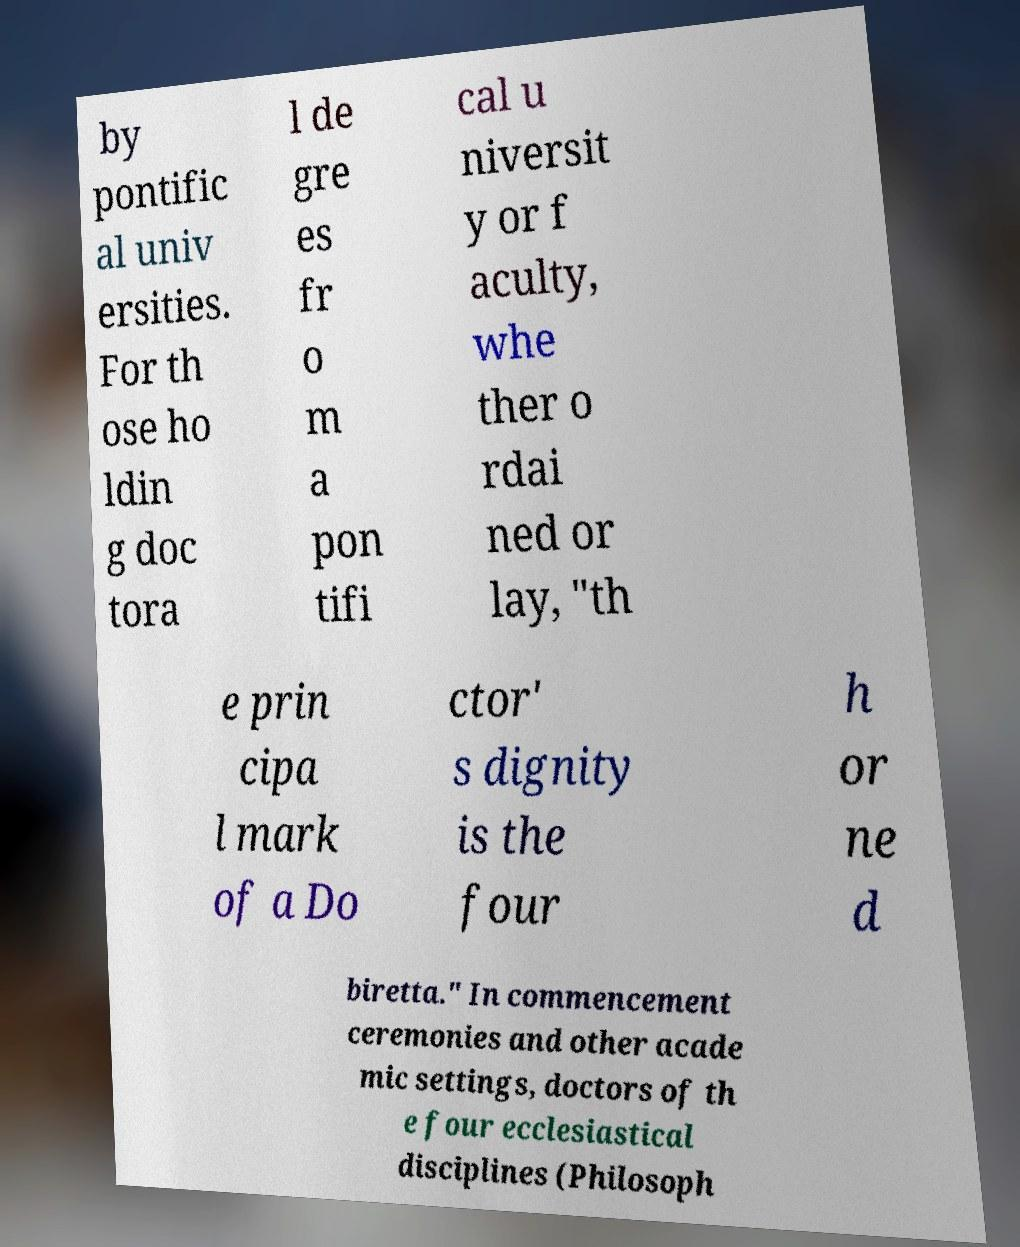There's text embedded in this image that I need extracted. Can you transcribe it verbatim? by pontific al univ ersities. For th ose ho ldin g doc tora l de gre es fr o m a pon tifi cal u niversit y or f aculty, whe ther o rdai ned or lay, "th e prin cipa l mark of a Do ctor' s dignity is the four h or ne d biretta." In commencement ceremonies and other acade mic settings, doctors of th e four ecclesiastical disciplines (Philosoph 